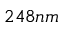<formula> <loc_0><loc_0><loc_500><loc_500>2 4 8 n m</formula> 